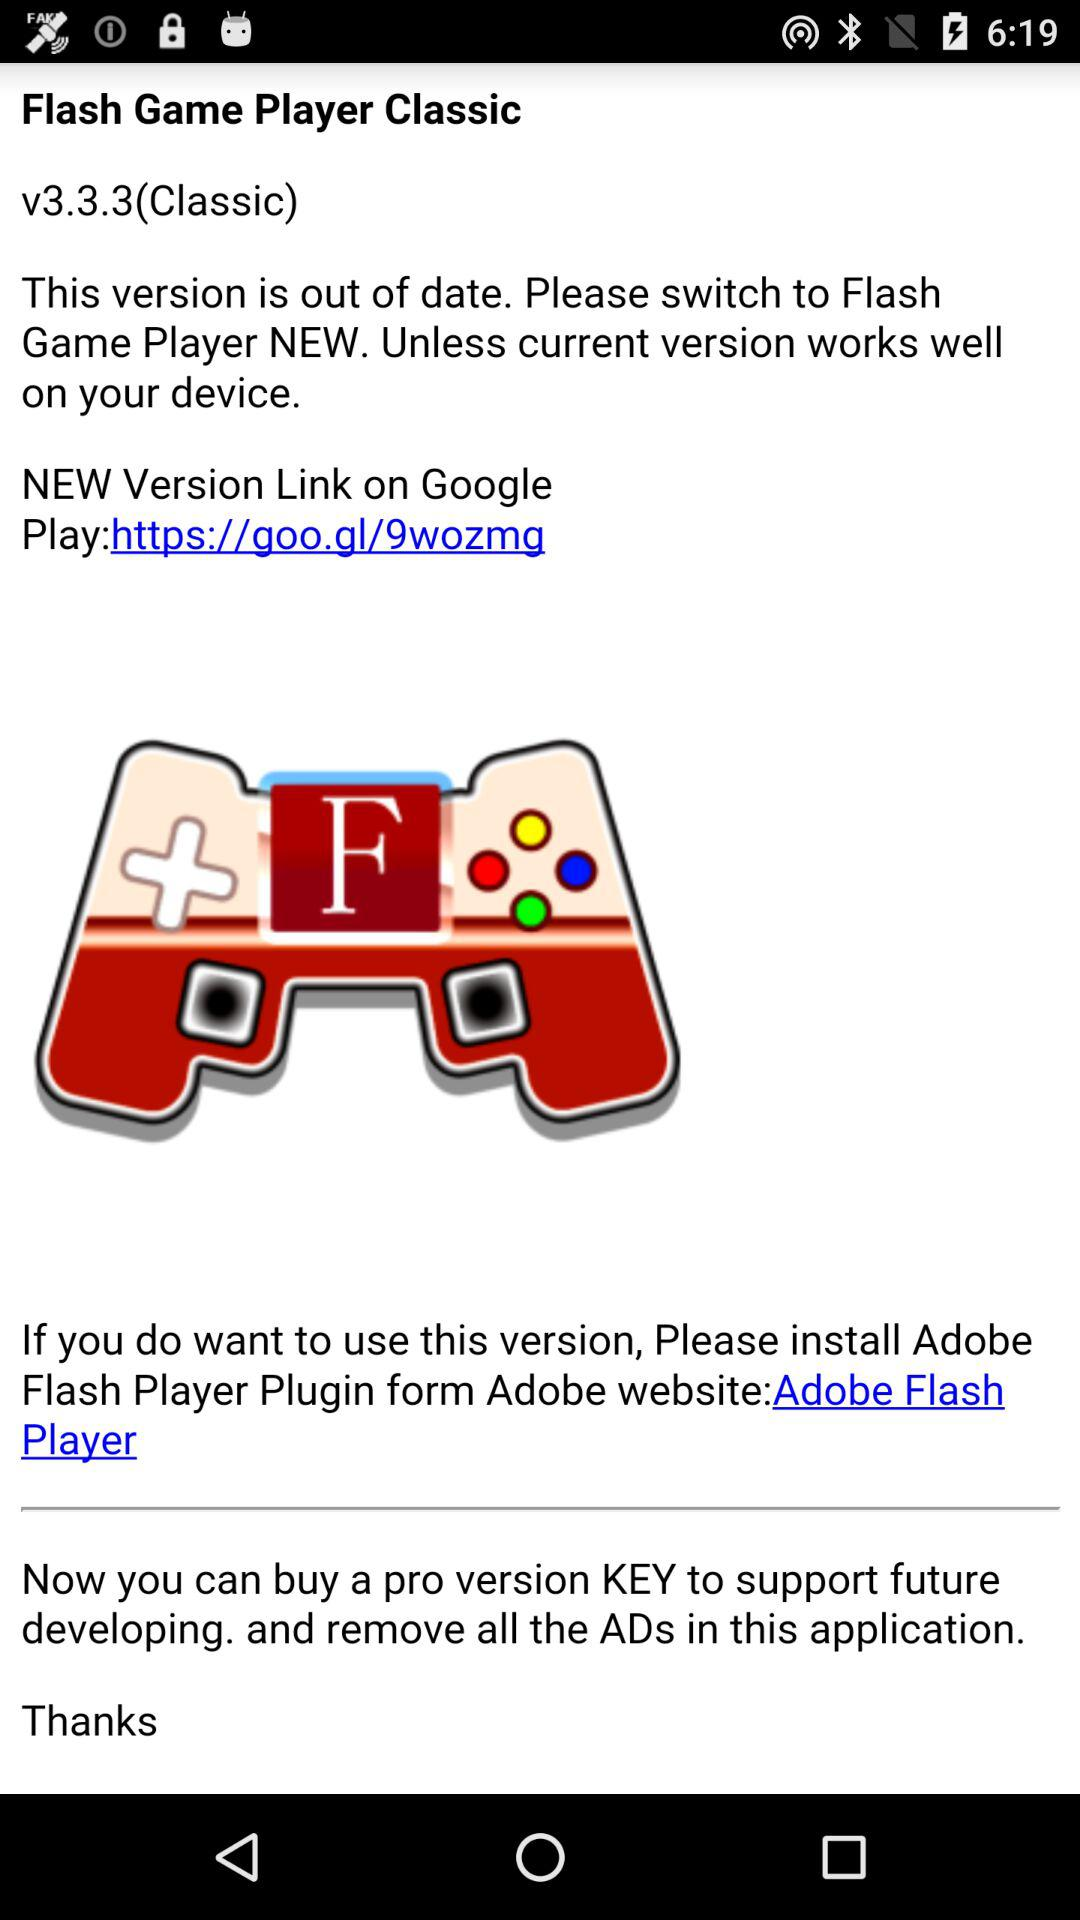How many versions of Flash Game Player are available?
Answer the question using a single word or phrase. 2 